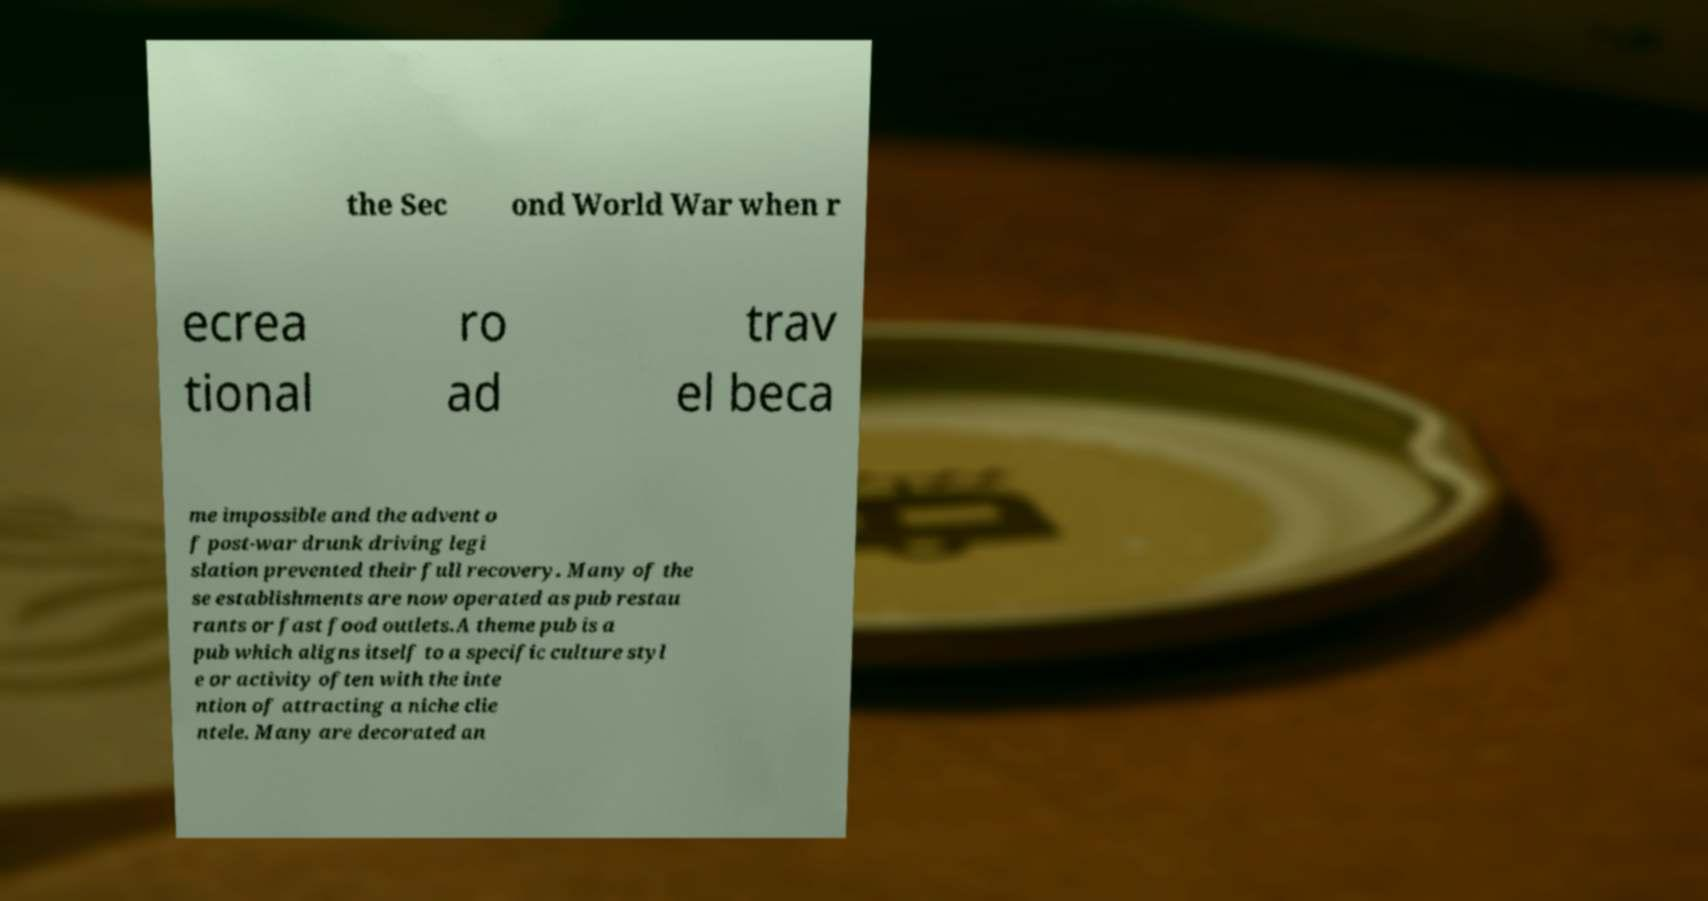What messages or text are displayed in this image? I need them in a readable, typed format. the Sec ond World War when r ecrea tional ro ad trav el beca me impossible and the advent o f post-war drunk driving legi slation prevented their full recovery. Many of the se establishments are now operated as pub restau rants or fast food outlets.A theme pub is a pub which aligns itself to a specific culture styl e or activity often with the inte ntion of attracting a niche clie ntele. Many are decorated an 